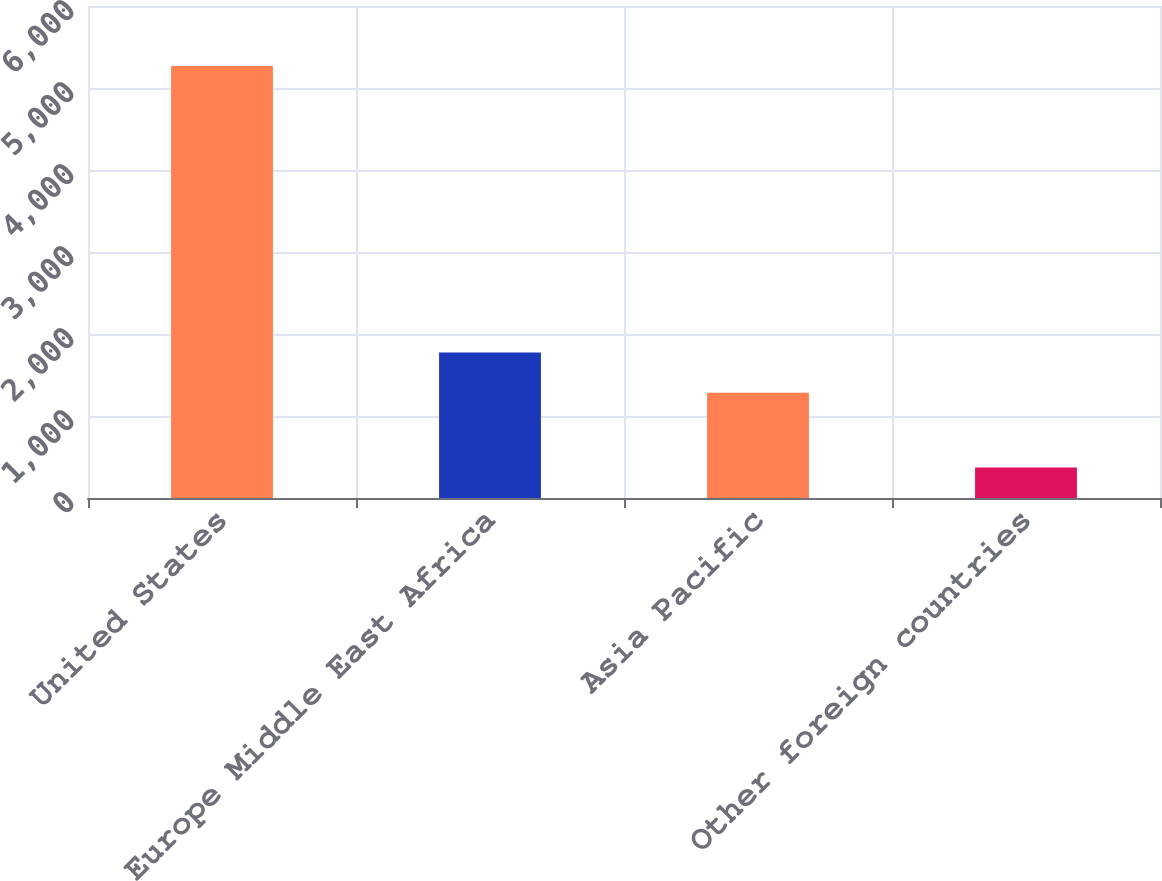Convert chart to OTSL. <chart><loc_0><loc_0><loc_500><loc_500><bar_chart><fcel>United States<fcel>Europe Middle East Africa<fcel>Asia Pacific<fcel>Other foreign countries<nl><fcel>5269<fcel>1774.8<fcel>1285<fcel>371<nl></chart> 